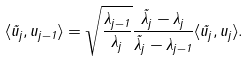Convert formula to latex. <formula><loc_0><loc_0><loc_500><loc_500>\langle \tilde { u } _ { j } , u _ { j - 1 } \rangle = \sqrt { \frac { \lambda _ { j - 1 } } { \lambda _ { j } } } \frac { \tilde { \lambda } _ { j } - \lambda _ { j } } { \tilde { \lambda } _ { j } - \lambda _ { j - 1 } } \langle \tilde { u } _ { j } , u _ { j } \rangle .</formula> 